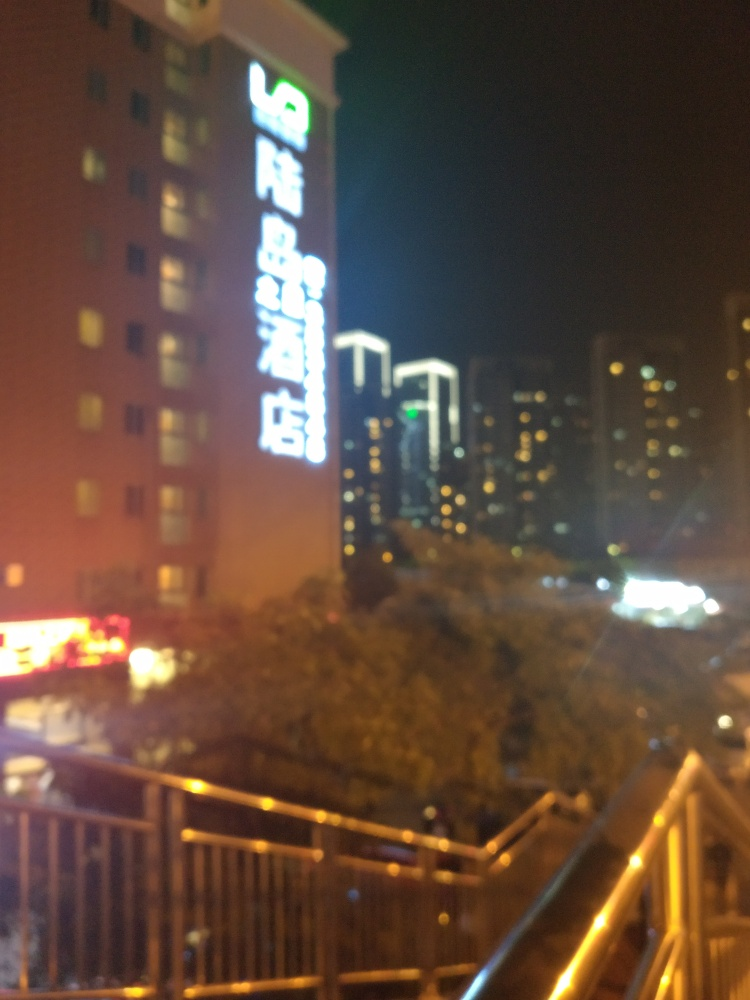What time of day do you think this photo was taken? Given the darkness in the background and the artificial lights being on, it appears to be taken at night. 